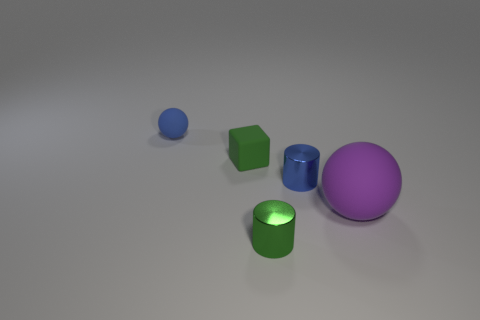Subtract all blue cylinders. How many cylinders are left? 1 Add 5 gray blocks. How many objects exist? 10 Subtract all blocks. How many objects are left? 4 Subtract 2 cylinders. How many cylinders are left? 0 Add 2 green shiny cylinders. How many green shiny cylinders are left? 3 Add 4 big purple objects. How many big purple objects exist? 5 Subtract 0 yellow cubes. How many objects are left? 5 Subtract all gray cubes. Subtract all cyan spheres. How many cubes are left? 1 Subtract all tiny purple matte balls. Subtract all matte spheres. How many objects are left? 3 